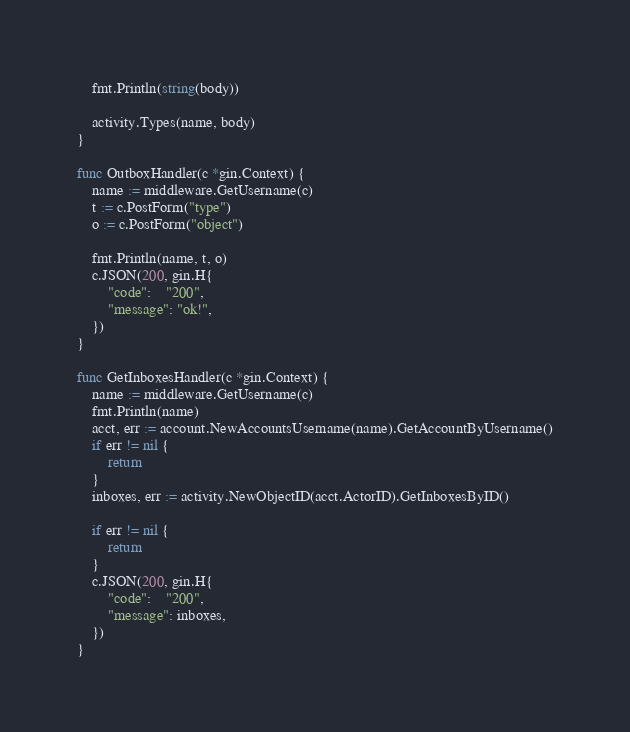Convert code to text. <code><loc_0><loc_0><loc_500><loc_500><_Go_>	fmt.Println(string(body))

	activity.Types(name, body)
}

func OutboxHandler(c *gin.Context) {
	name := middleware.GetUsername(c)
	t := c.PostForm("type")
	o := c.PostForm("object")

	fmt.Println(name, t, o)
	c.JSON(200, gin.H{
		"code":    "200",
		"message": "ok!",
	})
}

func GetInboxesHandler(c *gin.Context) {
	name := middleware.GetUsername(c)
	fmt.Println(name)
	acct, err := account.NewAccountsUsername(name).GetAccountByUsername()
	if err != nil {
		return
	}
	inboxes, err := activity.NewObjectID(acct.ActorID).GetInboxesByID()

	if err != nil {
		return
	}
	c.JSON(200, gin.H{
		"code":    "200",
		"message": inboxes,
	})
}
</code> 